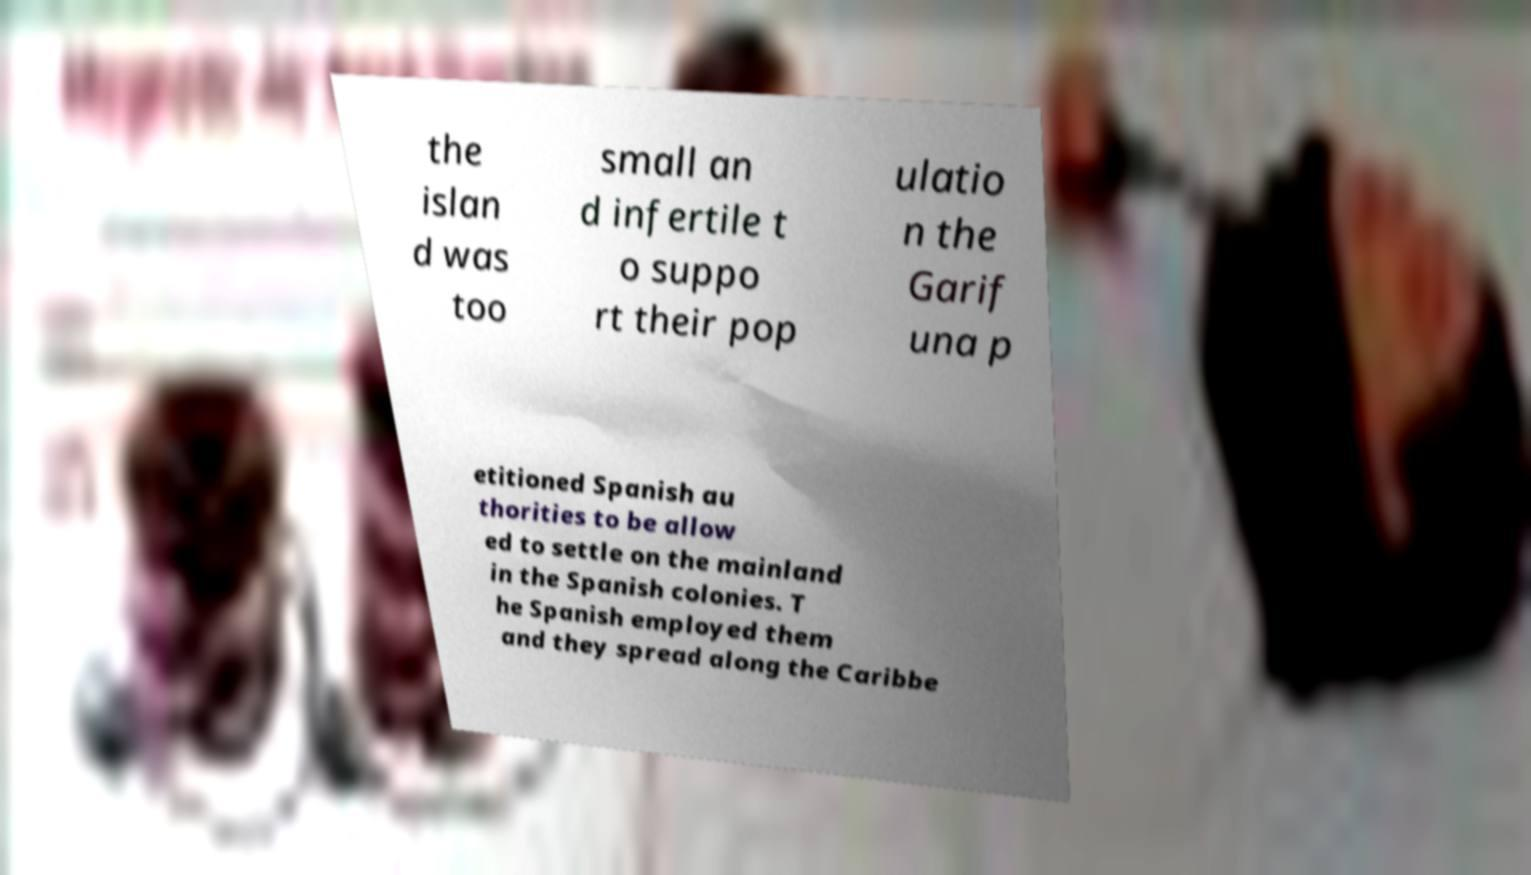Can you read and provide the text displayed in the image?This photo seems to have some interesting text. Can you extract and type it out for me? the islan d was too small an d infertile t o suppo rt their pop ulatio n the Garif una p etitioned Spanish au thorities to be allow ed to settle on the mainland in the Spanish colonies. T he Spanish employed them and they spread along the Caribbe 